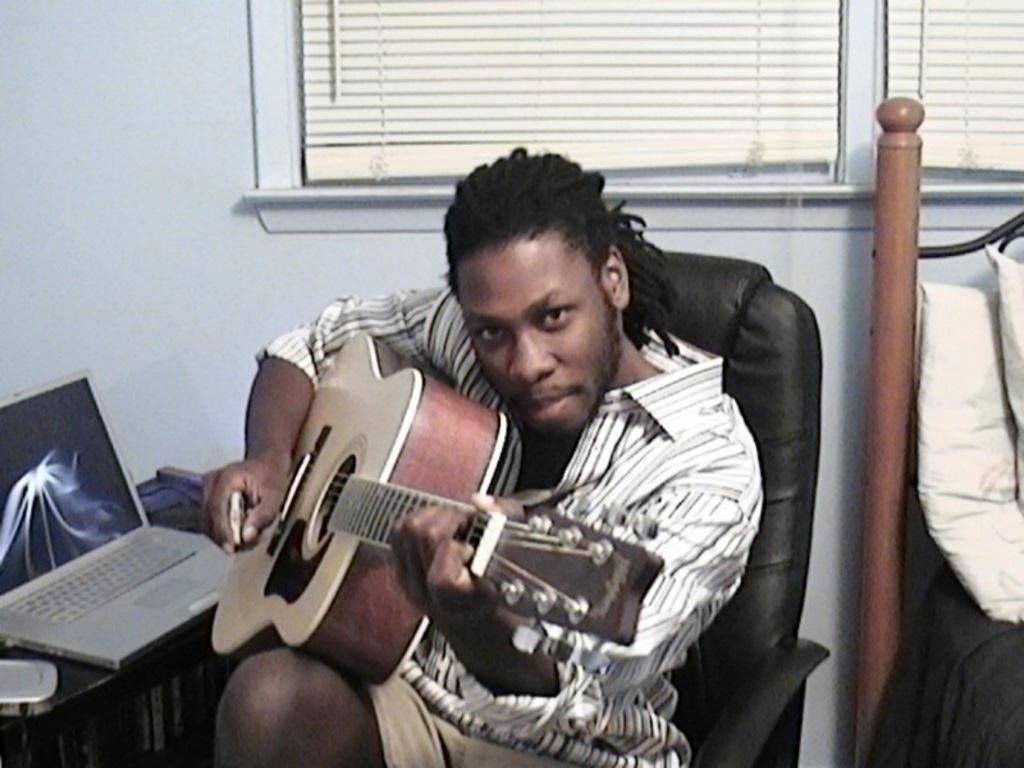How would you summarize this image in a sentence or two? The image looks like it is clicked inside a room. There is man sitting and playing the guitar and also facing the camera. To the left, there is a laptop. To the right, there is a cot and bed. In the background there is a window and window blind. 